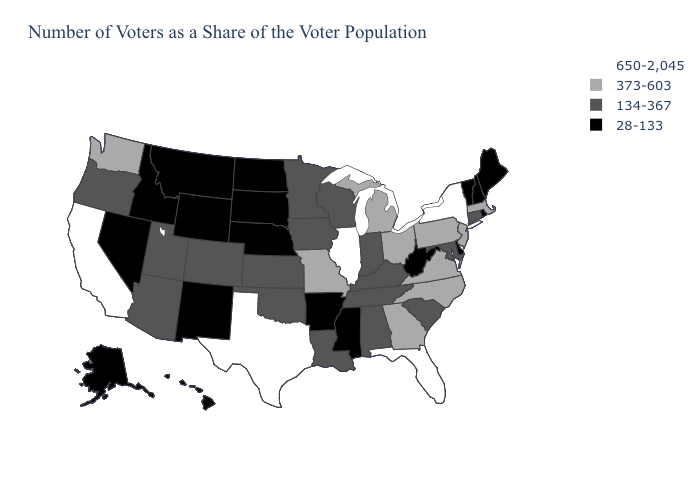Name the states that have a value in the range 650-2,045?
Concise answer only. California, Florida, Illinois, New York, Texas. Name the states that have a value in the range 650-2,045?
Concise answer only. California, Florida, Illinois, New York, Texas. Name the states that have a value in the range 650-2,045?
Quick response, please. California, Florida, Illinois, New York, Texas. Name the states that have a value in the range 134-367?
Keep it brief. Alabama, Arizona, Colorado, Connecticut, Indiana, Iowa, Kansas, Kentucky, Louisiana, Maryland, Minnesota, Oklahoma, Oregon, South Carolina, Tennessee, Utah, Wisconsin. Does Illinois have the highest value in the MidWest?
Give a very brief answer. Yes. Name the states that have a value in the range 650-2,045?
Short answer required. California, Florida, Illinois, New York, Texas. What is the lowest value in the USA?
Answer briefly. 28-133. Among the states that border Mississippi , does Arkansas have the lowest value?
Be succinct. Yes. Among the states that border Kentucky , does Illinois have the highest value?
Short answer required. Yes. What is the lowest value in the MidWest?
Concise answer only. 28-133. Does the first symbol in the legend represent the smallest category?
Keep it brief. No. What is the value of Montana?
Be succinct. 28-133. Which states have the lowest value in the Northeast?
Short answer required. Maine, New Hampshire, Rhode Island, Vermont. Does Idaho have the lowest value in the West?
Write a very short answer. Yes. 